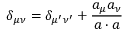Convert formula to latex. <formula><loc_0><loc_0><loc_500><loc_500>\delta _ { \mu \nu } = \delta _ { \mu ^ { \prime } \nu ^ { \prime } } + { \frac { a _ { \mu } a _ { \nu } } { a \cdot a } }</formula> 